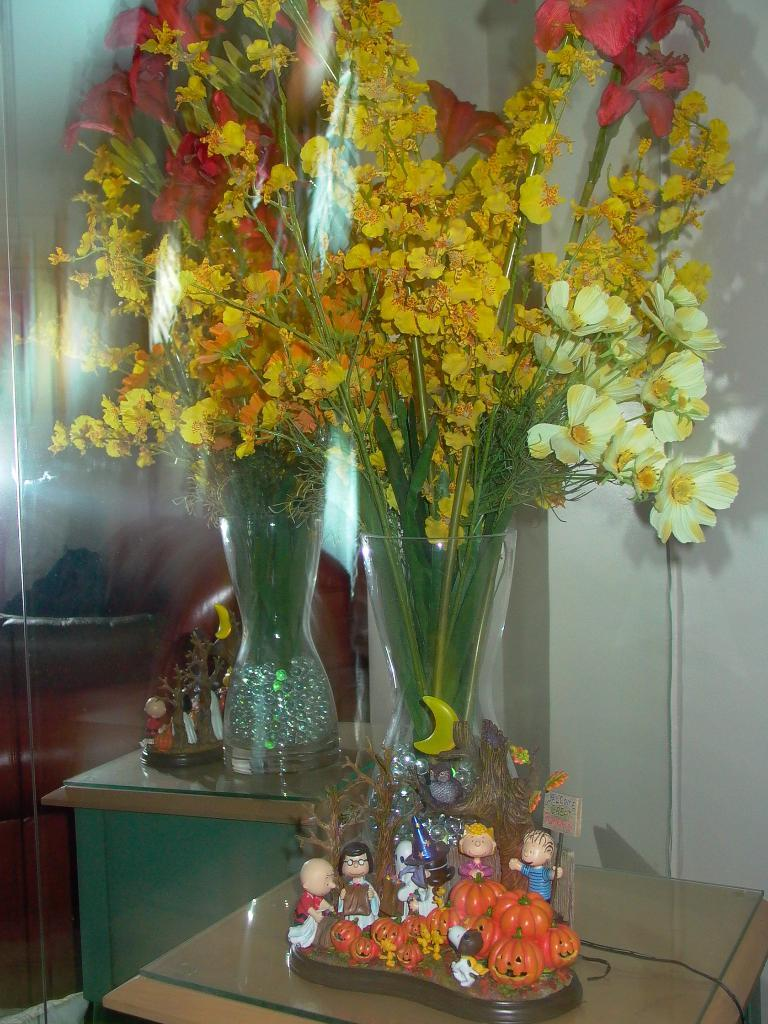What type of living organisms can be seen in the image? There are flowers in the image. Can you tell me how much trouble the flowers are causing in the image? There is no indication of trouble or any problematic situation involving the flowers in the image. 